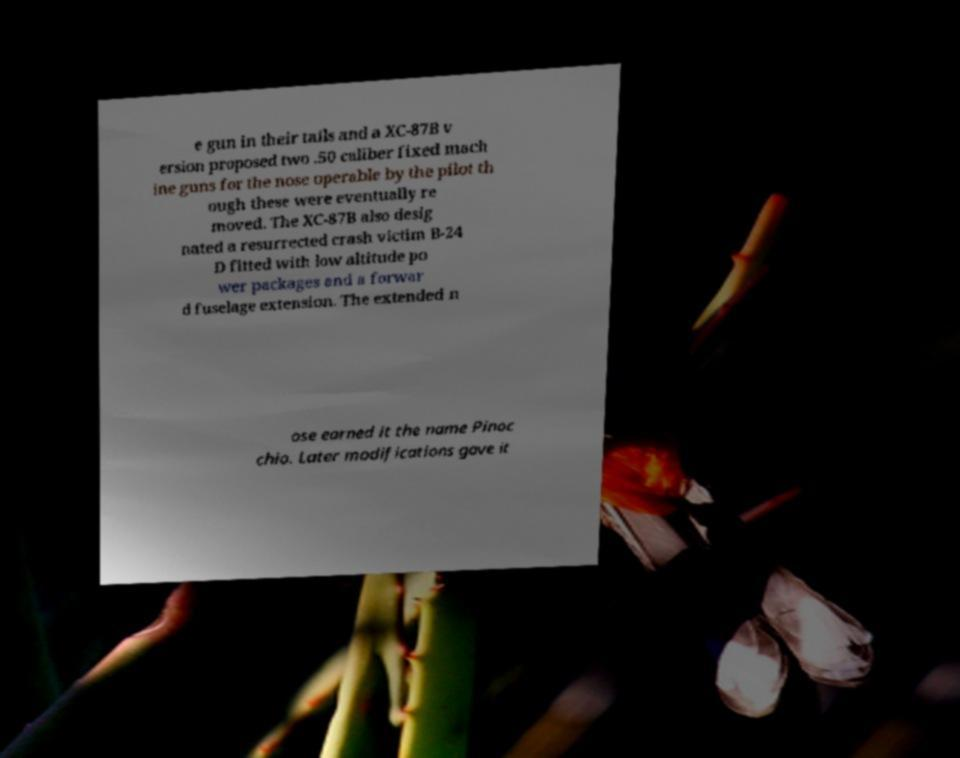What messages or text are displayed in this image? I need them in a readable, typed format. e gun in their tails and a XC-87B v ersion proposed two .50 caliber fixed mach ine guns for the nose operable by the pilot th ough these were eventually re moved. The XC-87B also desig nated a resurrected crash victim B-24 D fitted with low altitude po wer packages and a forwar d fuselage extension. The extended n ose earned it the name Pinoc chio. Later modifications gave it 